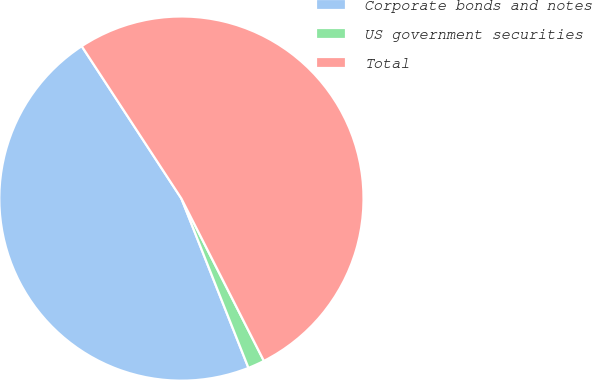<chart> <loc_0><loc_0><loc_500><loc_500><pie_chart><fcel>Corporate bonds and notes<fcel>US government securities<fcel>Total<nl><fcel>46.78%<fcel>1.48%<fcel>51.74%<nl></chart> 